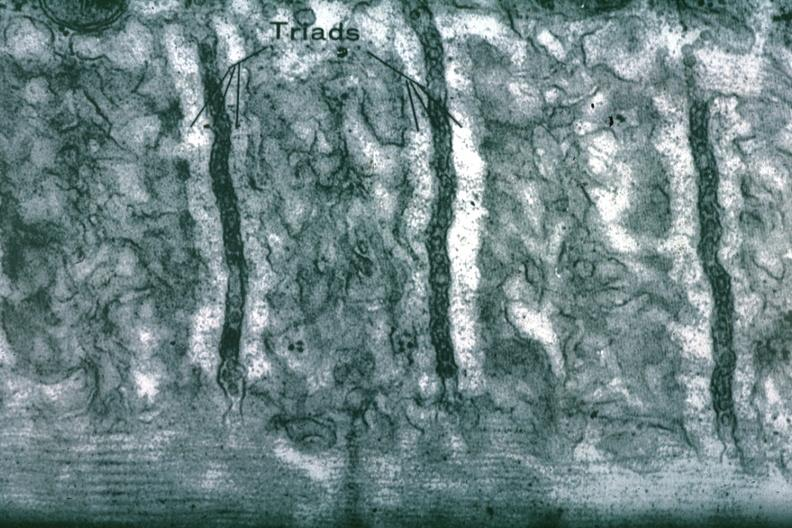does this image show sarcoplasmic reticulum?
Answer the question using a single word or phrase. Yes 